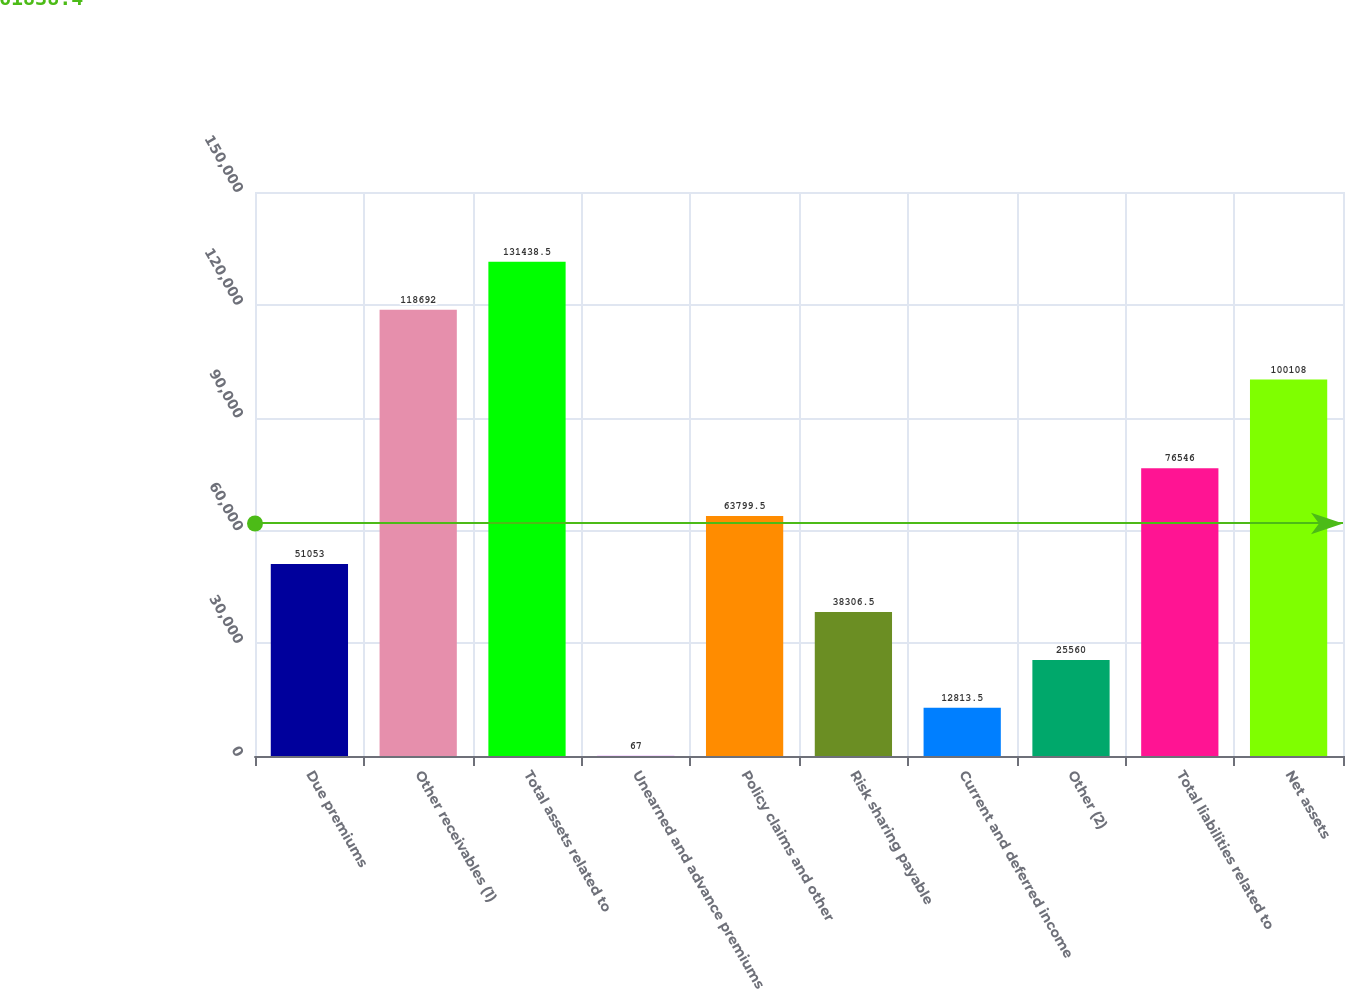Convert chart to OTSL. <chart><loc_0><loc_0><loc_500><loc_500><bar_chart><fcel>Due premiums<fcel>Other receivables (1)<fcel>Total assets related to<fcel>Unearned and advance premiums<fcel>Policy claims and other<fcel>Risk sharing payable<fcel>Current and deferred income<fcel>Other (2)<fcel>Total liabilities related to<fcel>Net assets<nl><fcel>51053<fcel>118692<fcel>131438<fcel>67<fcel>63799.5<fcel>38306.5<fcel>12813.5<fcel>25560<fcel>76546<fcel>100108<nl></chart> 